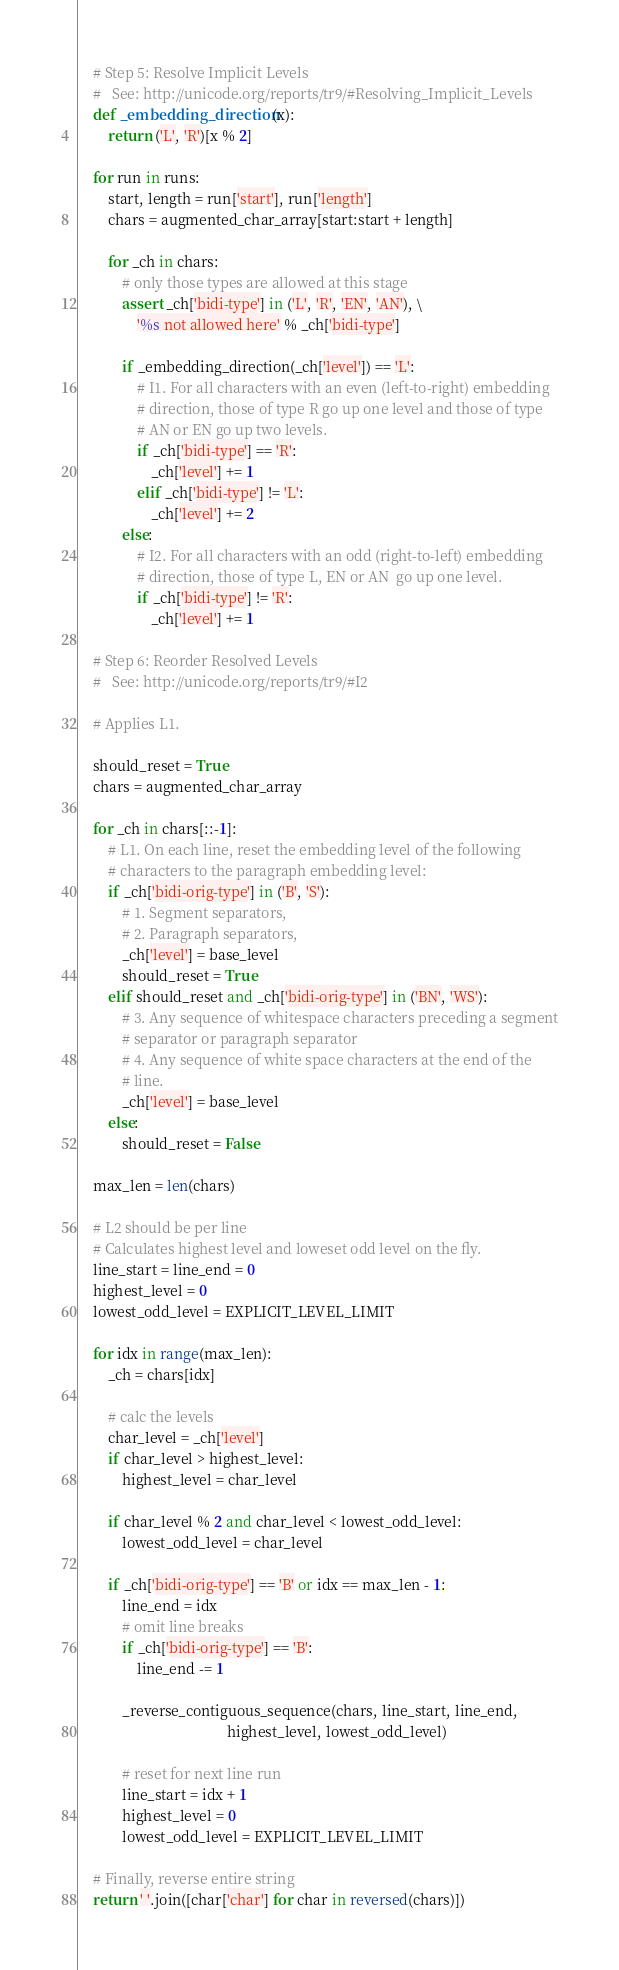Convert code to text. <code><loc_0><loc_0><loc_500><loc_500><_Python_>    # Step 5: Resolve Implicit Levels
    #   See: http://unicode.org/reports/tr9/#Resolving_Implicit_Levels
    def _embedding_direction(x):
        return ('L', 'R')[x % 2]

    for run in runs:
        start, length = run['start'], run['length']
        chars = augmented_char_array[start:start + length]

        for _ch in chars:
            # only those types are allowed at this stage
            assert _ch['bidi-type'] in ('L', 'R', 'EN', 'AN'), \
                '%s not allowed here' % _ch['bidi-type']

            if _embedding_direction(_ch['level']) == 'L':
                # I1. For all characters with an even (left-to-right) embedding
                # direction, those of type R go up one level and those of type
                # AN or EN go up two levels.
                if _ch['bidi-type'] == 'R':
                    _ch['level'] += 1
                elif _ch['bidi-type'] != 'L':
                    _ch['level'] += 2
            else:
                # I2. For all characters with an odd (right-to-left) embedding
                # direction, those of type L, EN or AN  go up one level.
                if _ch['bidi-type'] != 'R':
                    _ch['level'] += 1

    # Step 6: Reorder Resolved Levels
    #   See: http://unicode.org/reports/tr9/#I2

    # Applies L1.

    should_reset = True
    chars = augmented_char_array

    for _ch in chars[::-1]:
        # L1. On each line, reset the embedding level of the following
        # characters to the paragraph embedding level:
        if _ch['bidi-orig-type'] in ('B', 'S'):
            # 1. Segment separators,
            # 2. Paragraph separators,
            _ch['level'] = base_level
            should_reset = True
        elif should_reset and _ch['bidi-orig-type'] in ('BN', 'WS'):
            # 3. Any sequence of whitespace characters preceding a segment
            # separator or paragraph separator
            # 4. Any sequence of white space characters at the end of the
            # line.
            _ch['level'] = base_level
        else:
            should_reset = False

    max_len = len(chars)

    # L2 should be per line
    # Calculates highest level and loweset odd level on the fly.
    line_start = line_end = 0
    highest_level = 0
    lowest_odd_level = EXPLICIT_LEVEL_LIMIT

    for idx in range(max_len):
        _ch = chars[idx]

        # calc the levels
        char_level = _ch['level']
        if char_level > highest_level:
            highest_level = char_level

        if char_level % 2 and char_level < lowest_odd_level:
            lowest_odd_level = char_level

        if _ch['bidi-orig-type'] == 'B' or idx == max_len - 1:
            line_end = idx
            # omit line breaks
            if _ch['bidi-orig-type'] == 'B':
                line_end -= 1

            _reverse_contiguous_sequence(chars, line_start, line_end,
                                         highest_level, lowest_odd_level)

            # reset for next line run
            line_start = idx + 1
            highest_level = 0
            lowest_odd_level = EXPLICIT_LEVEL_LIMIT

    # Finally, reverse entire string
    return ' '.join([char['char'] for char in reversed(chars)])
</code> 